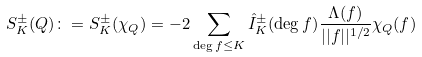Convert formula to latex. <formula><loc_0><loc_0><loc_500><loc_500>S _ { K } ^ { \pm } ( Q ) \colon = S ^ { \pm } _ { K } ( \chi _ { Q } ) = - 2 \sum _ { \deg f \leq K } \hat { I } ^ { \pm } _ { K } ( \deg f ) \frac { \Lambda ( f ) } { | | f | | ^ { 1 / 2 } } \chi _ { Q } ( f )</formula> 